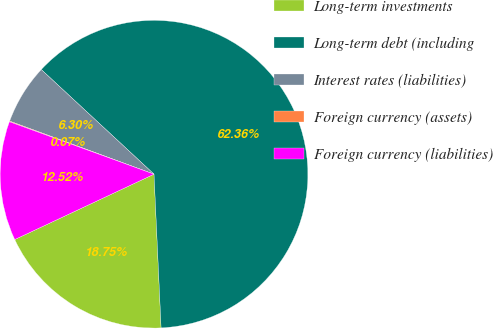Convert chart. <chart><loc_0><loc_0><loc_500><loc_500><pie_chart><fcel>Long-term investments<fcel>Long-term debt (including<fcel>Interest rates (liabilities)<fcel>Foreign currency (assets)<fcel>Foreign currency (liabilities)<nl><fcel>18.75%<fcel>62.36%<fcel>6.3%<fcel>0.07%<fcel>12.52%<nl></chart> 